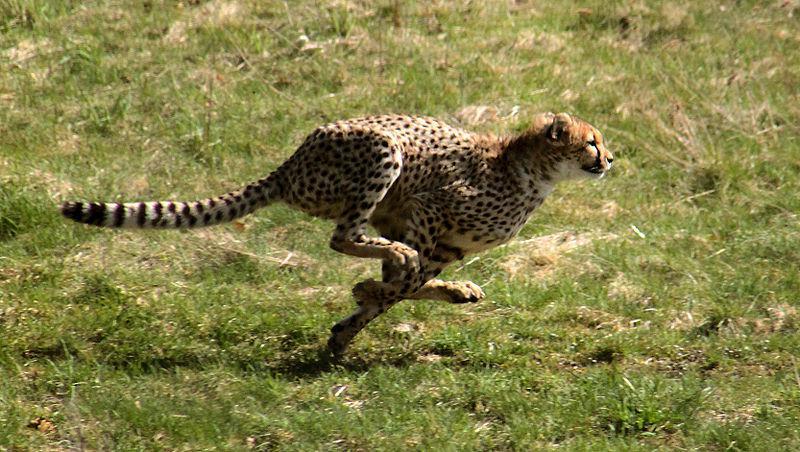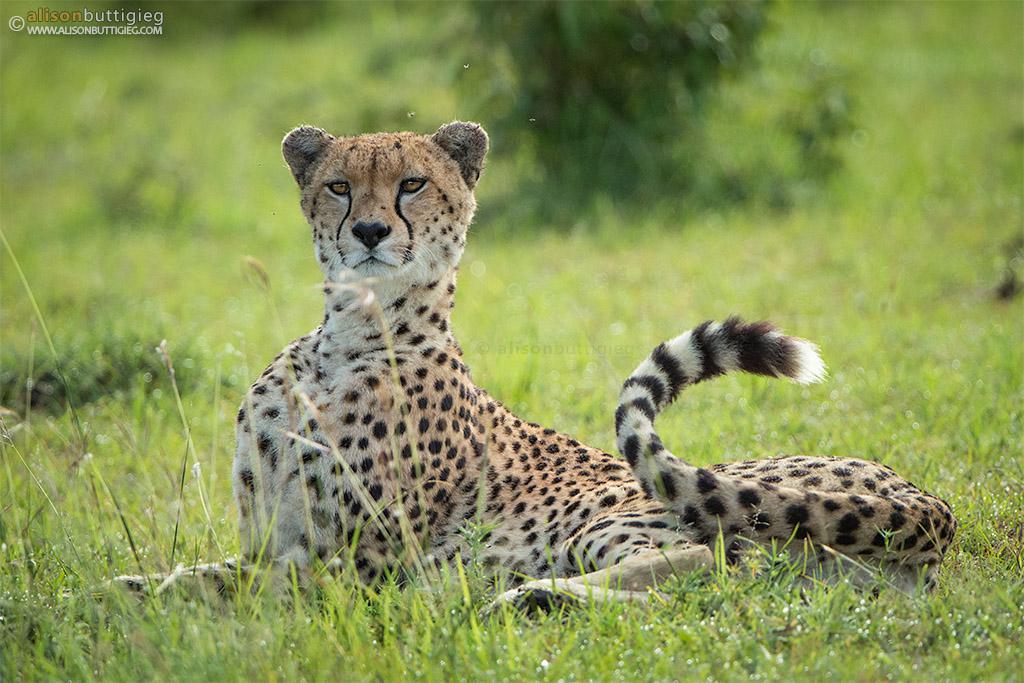The first image is the image on the left, the second image is the image on the right. Examine the images to the left and right. Is the description "Each image contains a single cheetah, with one image showing a rightward facing cheetah, and the other showing a forward-looking cheetah." accurate? Answer yes or no. Yes. The first image is the image on the left, the second image is the image on the right. Given the left and right images, does the statement "There are at least four leopards." hold true? Answer yes or no. No. 